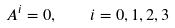<formula> <loc_0><loc_0><loc_500><loc_500>A ^ { i } = 0 , \quad i = 0 , 1 , 2 , 3</formula> 